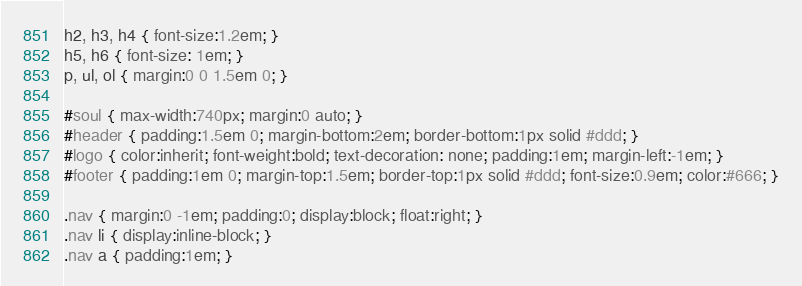Convert code to text. <code><loc_0><loc_0><loc_500><loc_500><_CSS_>h2, h3, h4 { font-size:1.2em; }
h5, h6 { font-size: 1em; }
p, ul, ol { margin:0 0 1.5em 0; }

#soul { max-width:740px; margin:0 auto; }
#header { padding:1.5em 0; margin-bottom:2em; border-bottom:1px solid #ddd; }
#logo { color:inherit; font-weight:bold; text-decoration: none; padding:1em; margin-left:-1em; }
#footer { padding:1em 0; margin-top:1.5em; border-top:1px solid #ddd; font-size:0.9em; color:#666; }

.nav { margin:0 -1em; padding:0; display:block; float:right; }
.nav li { display:inline-block; }
.nav a { padding:1em; }
</code> 